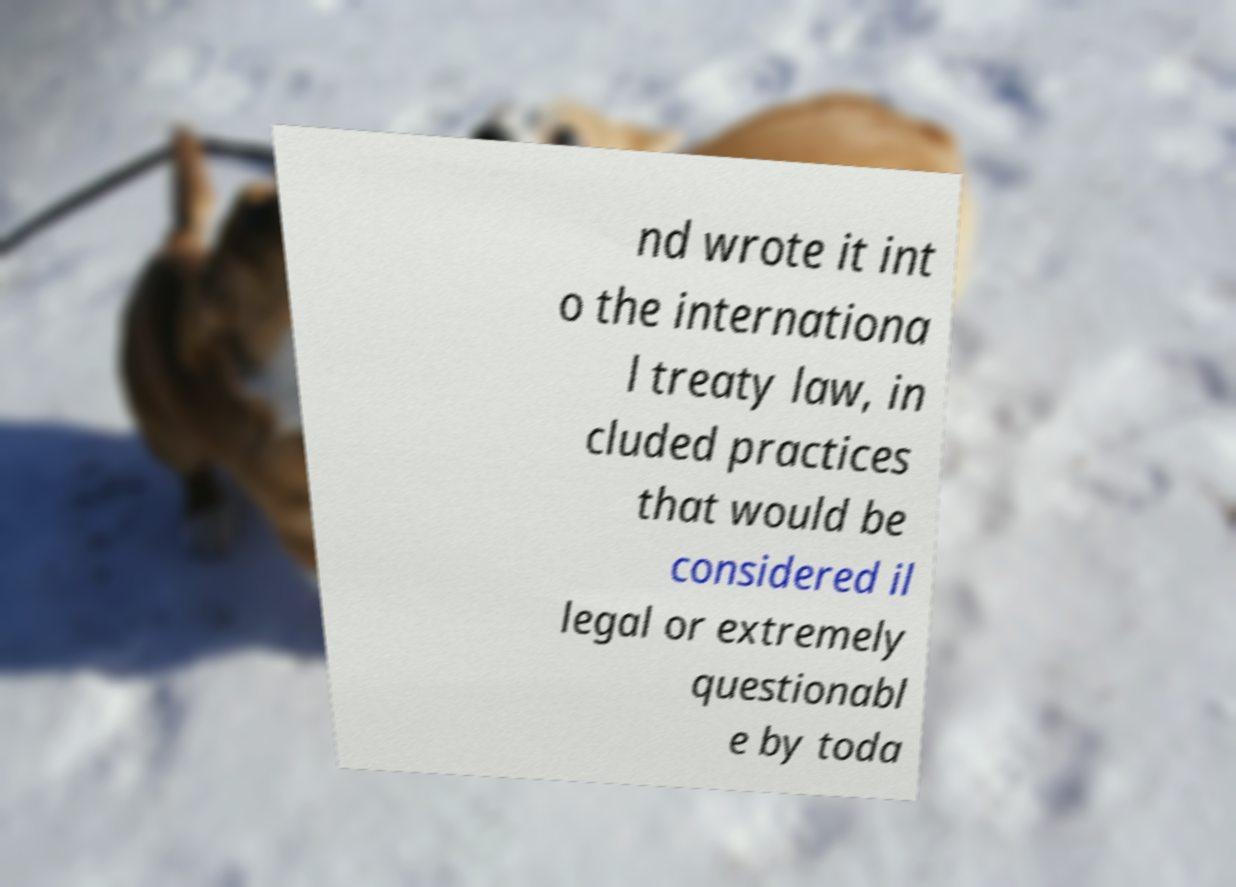Could you extract and type out the text from this image? nd wrote it int o the internationa l treaty law, in cluded practices that would be considered il legal or extremely questionabl e by toda 